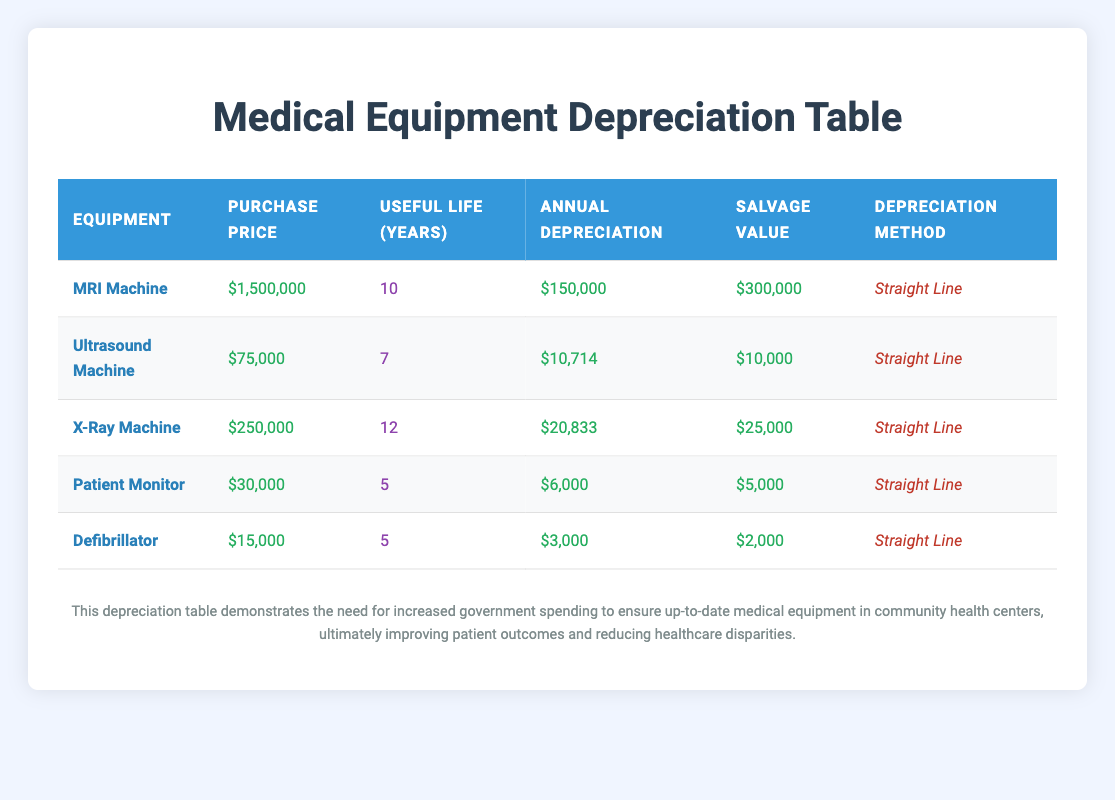What is the purchase price of the MRI Machine? The table explicitly lists the purchase price of the MRI Machine as $1,500,000, which can be found in the "Purchase Price" column next to the MRI Machine row.
Answer: $1,500,000 What is the salvage value of the Ultrasound Machine? The salvage value for the Ultrasound Machine is provided directly in the table under the "Salvage Value" column, which shows $10,000 next to the Ultrasound Machine row.
Answer: $10,000 Which piece of equipment has the highest annual depreciation? From the "Annual Depreciation" column, by comparing the values, the MRI Machine shows the highest annual depreciation of $150,000.
Answer: MRI Machine How much total annual depreciation do all pieces of equipment depreciate combined? By summing the annual depreciation figures: $150,000 (MRI) + $10,714 (Ultrasound) + $20,833 (X-Ray) + $6,000 (Patient Monitor) + $3,000 (Defibrillator) = $190,547 for the total annual depreciation.
Answer: $190,547 Is the useful life of the Defibrillator greater than 5 years? The useful life of the Defibrillator is stated in the table as 5 years, so it is not greater than 5 years meaning the statement is false.
Answer: No What is the average useful life of all the listed medical equipment? To find the average useful life, we sum all the useful life years: 10 (MRI) + 7 (Ultrasound) + 12 (X-Ray) + 5 (Patient Monitor) + 5 (Defibrillator) = 39. Then we divide this sum by the number of equipment (5), giving us an average of 39/5 = 7.8 years.
Answer: 7.8 years Does the Patient Monitor have a lower purchase price than the X-Ray Machine? The purchase price of the Patient Monitor is $30,000, while the X-Ray Machine's price is $250,000, confirming that the Patient Monitor's price is indeed lower, which makes the statement true.
Answer: Yes Which equipment has the longest useful life? By examining the "Useful Life (Years)" column, the X-Ray Machine has the longest lifespan at 12 years compared to others, which is clearly listed next to the X-Ray Machine in the corresponding row.
Answer: X-Ray Machine How much total depreciation will the medical equipment reach over their useful lives? To find the total depreciation, we calculate each piece's total depreciation by multiplying the annual depreciation by their useful life: MRI ($150,000 x 10) + Ultrasound ($10,714 x 7) + X-Ray ($20,833 x 12) + Patient Monitor ($6,000 x 5) + Defibrillator ($3,000 x 5) = $1,500,000 + $74,998 + $249,996 + $30,000 + $15,000 = $1,869,994. Thus the total depreciation over their useful lives is $1,869,994.
Answer: $1,869,994 